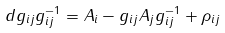<formula> <loc_0><loc_0><loc_500><loc_500>d g _ { i j } g ^ { - 1 } _ { i j } = A _ { i } - g _ { i j } A _ { j } g _ { i j } ^ { - 1 } + \rho _ { i j }</formula> 